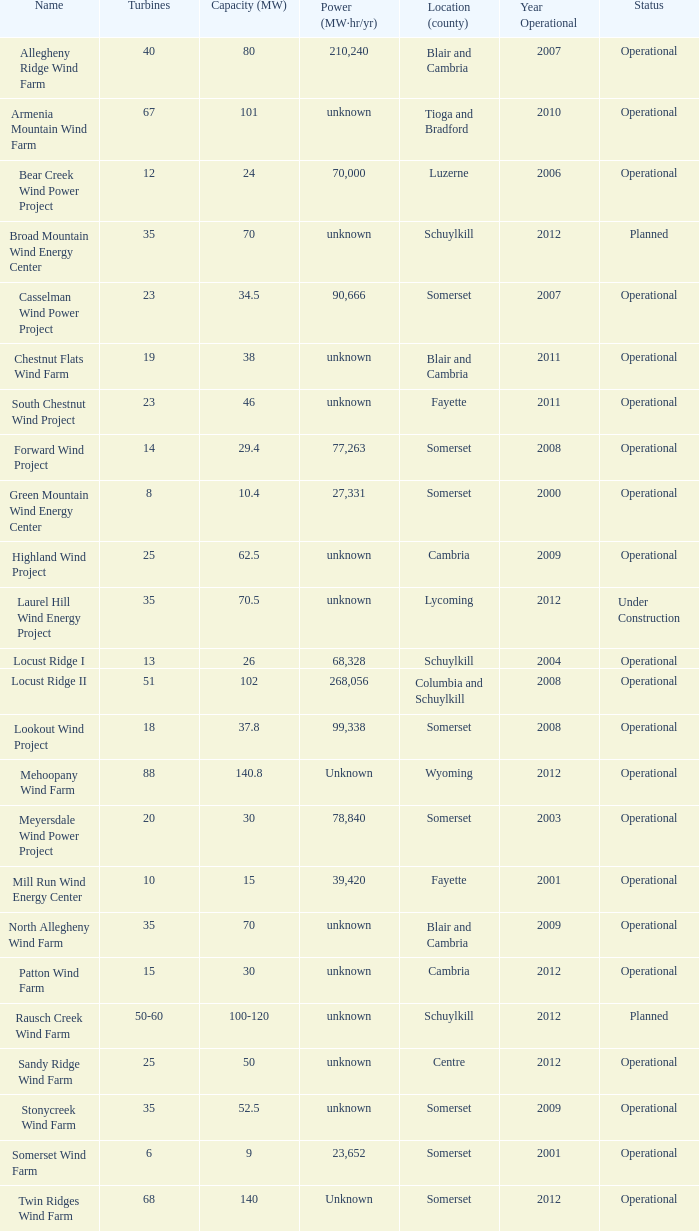What farm has a capacity of 70 and is operational? North Allegheny Wind Farm. 